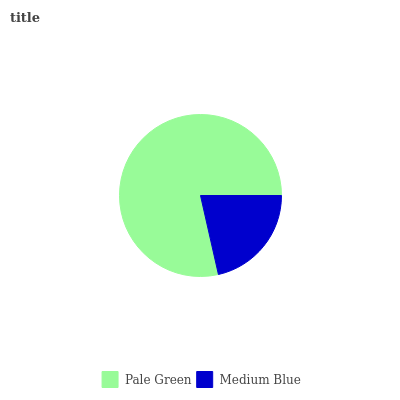Is Medium Blue the minimum?
Answer yes or no. Yes. Is Pale Green the maximum?
Answer yes or no. Yes. Is Medium Blue the maximum?
Answer yes or no. No. Is Pale Green greater than Medium Blue?
Answer yes or no. Yes. Is Medium Blue less than Pale Green?
Answer yes or no. Yes. Is Medium Blue greater than Pale Green?
Answer yes or no. No. Is Pale Green less than Medium Blue?
Answer yes or no. No. Is Pale Green the high median?
Answer yes or no. Yes. Is Medium Blue the low median?
Answer yes or no. Yes. Is Medium Blue the high median?
Answer yes or no. No. Is Pale Green the low median?
Answer yes or no. No. 